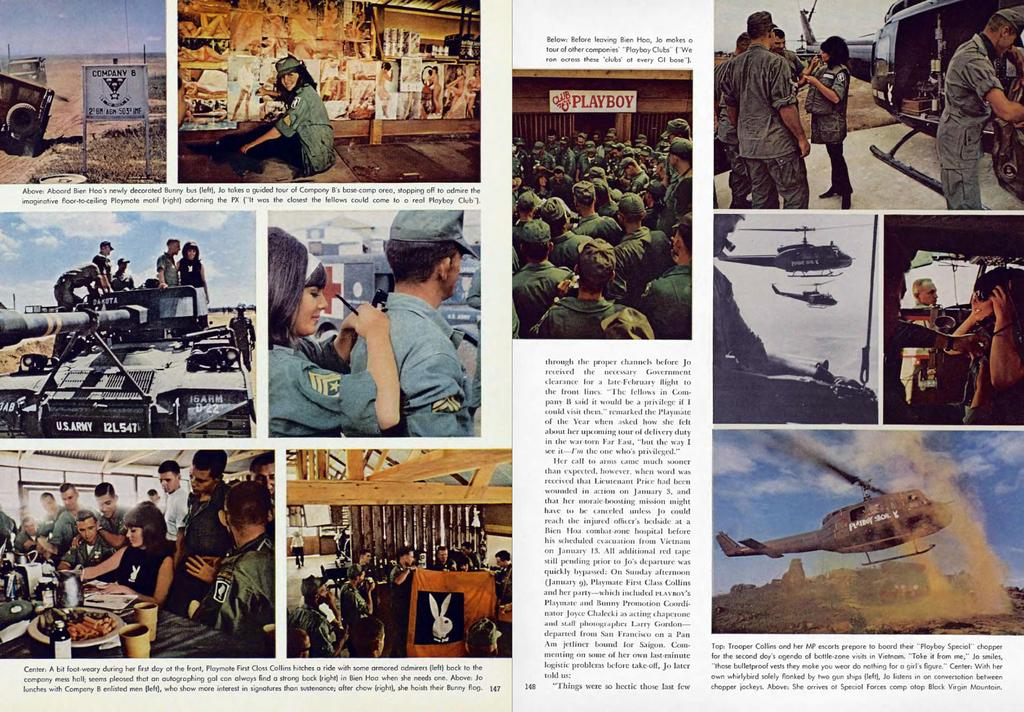Provide a one-sentence caption for the provided image. A magazine is showing photos from Vietnam and a Playboy sign. 